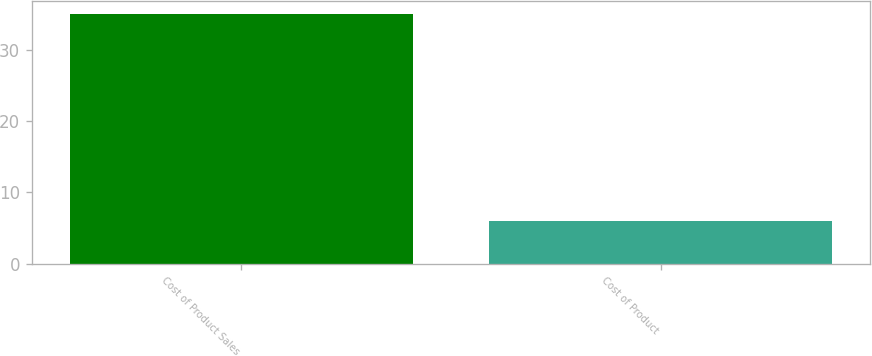Convert chart. <chart><loc_0><loc_0><loc_500><loc_500><bar_chart><fcel>Cost of Product Sales<fcel>Cost of Product<nl><fcel>35<fcel>6<nl></chart> 